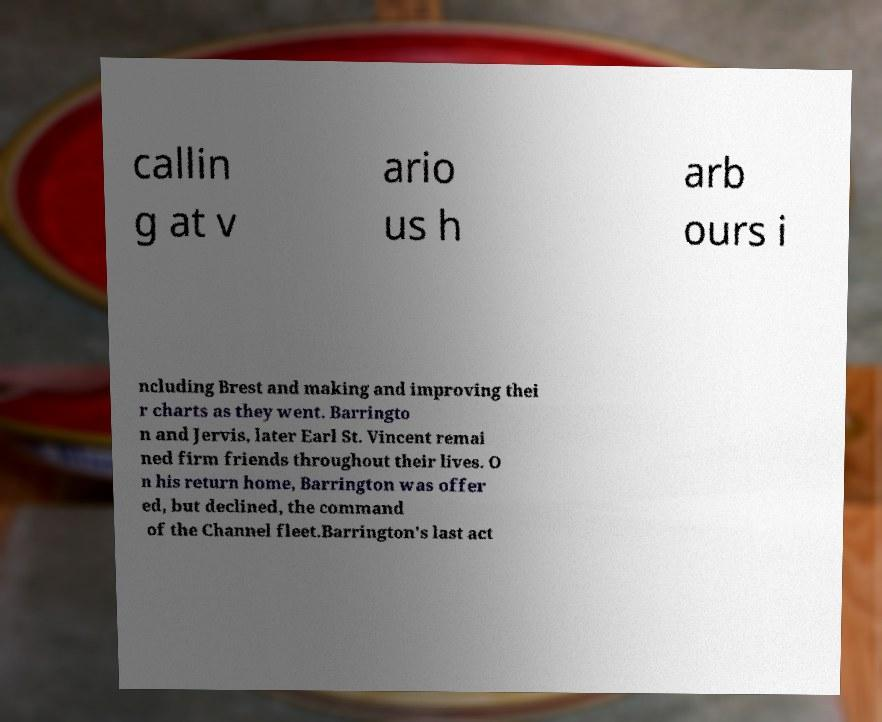Can you read and provide the text displayed in the image?This photo seems to have some interesting text. Can you extract and type it out for me? callin g at v ario us h arb ours i ncluding Brest and making and improving thei r charts as they went. Barringto n and Jervis, later Earl St. Vincent remai ned firm friends throughout their lives. O n his return home, Barrington was offer ed, but declined, the command of the Channel fleet.Barrington's last act 